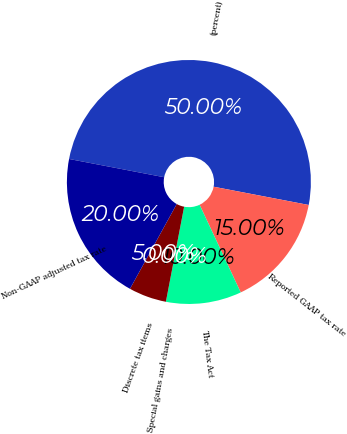<chart> <loc_0><loc_0><loc_500><loc_500><pie_chart><fcel>(percent)<fcel>Reported GAAP tax rate<fcel>The Tax Act<fcel>Special gains and charges<fcel>Discrete tax items<fcel>Non-GAAP adjusted tax rate<nl><fcel>50.0%<fcel>15.0%<fcel>10.0%<fcel>0.0%<fcel>5.0%<fcel>20.0%<nl></chart> 